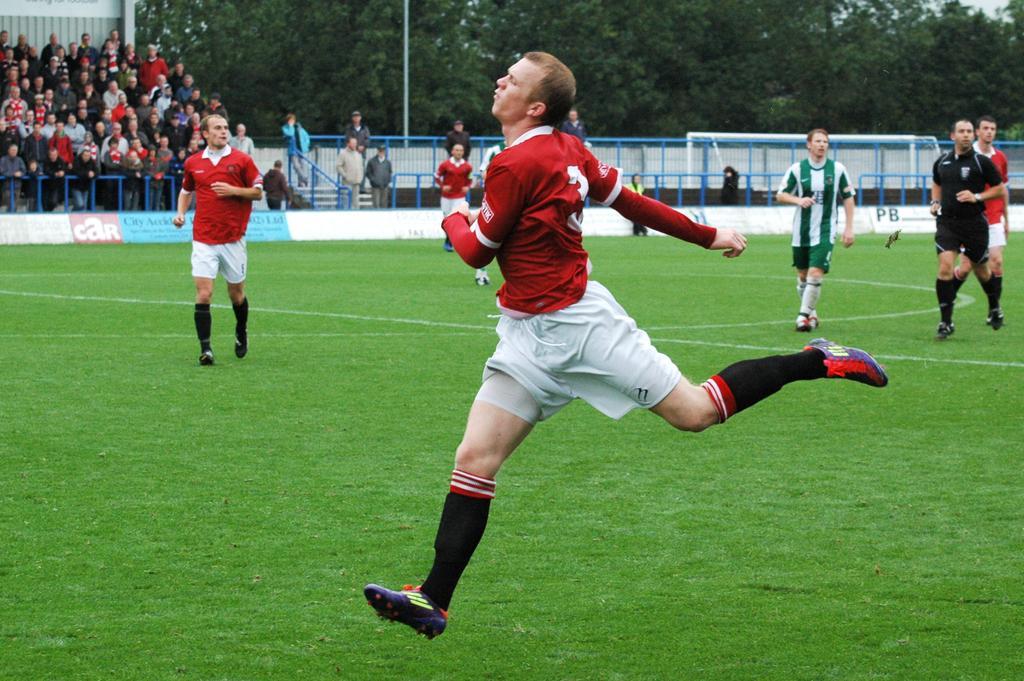In one or two sentences, can you explain what this image depicts? In this image, we can see people running on the ground and in the background, we can see railings, trees, a pole and there is a crowd and a wall. 